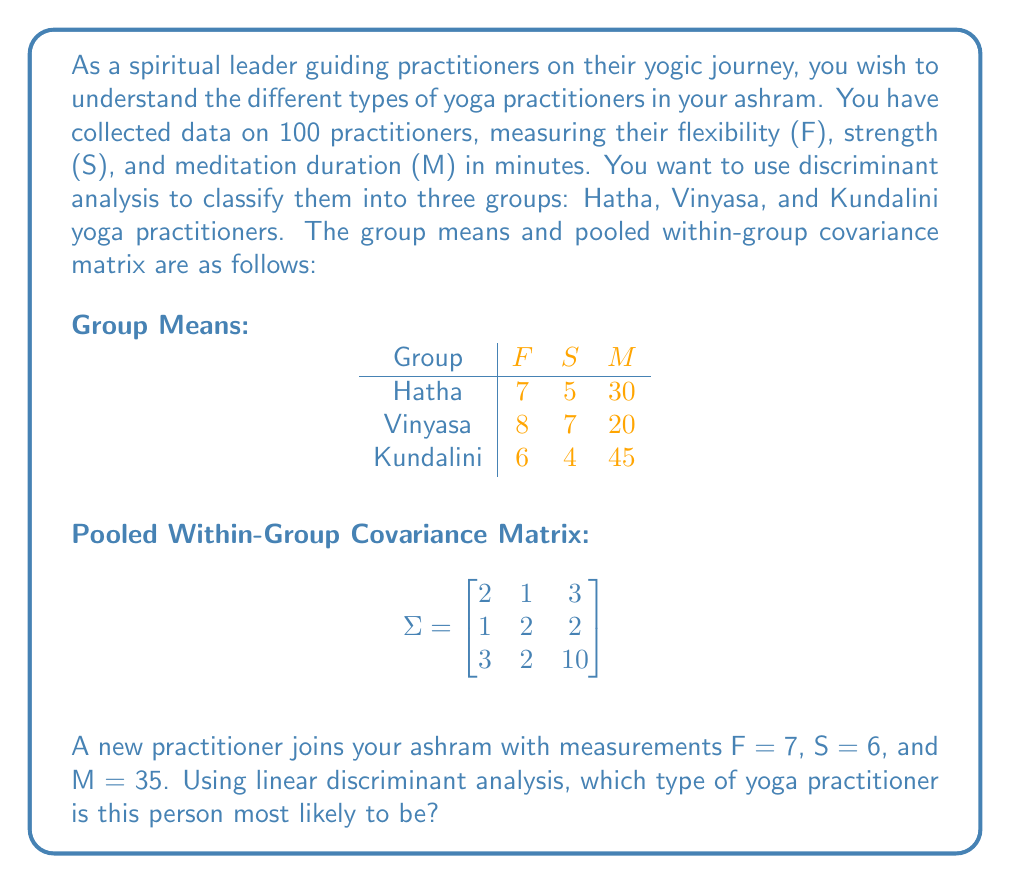Could you help me with this problem? To solve this problem using linear discriminant analysis, we'll follow these steps:

1) The linear discriminant function for each group is given by:
   $$d_k(x) = x^T \Sigma^{-1} \mu_k - \frac{1}{2} \mu_k^T \Sigma^{-1} \mu_k + \ln(p_k)$$
   where $x$ is the new observation, $\mu_k$ is the mean vector for group $k$, $\Sigma$ is the pooled within-group covariance matrix, and $p_k$ is the prior probability for group $k$.

2) Assuming equal prior probabilities, we can ignore the $\ln(p_k)$ term.

3) First, we need to find $\Sigma^{-1}$:
   $$\Sigma^{-1} = \begin{bmatrix}
   0.5714 & -0.1429 & -0.1714 \\
   -0.1429 & 0.5714 & -0.0571 \\
   -0.1714 & -0.0571 & 0.1429
   \end{bmatrix}$$

4) Now, let's calculate $\Sigma^{-1} \mu_k$ for each group:

   For Hatha: $\Sigma^{-1} \mu_\text{Hatha} = [1.2857, 1.0000, -0.4286]^T$
   For Vinyasa: $\Sigma^{-1} \mu_\text{Vinyasa} = [2.0000, 1.8571, -0.8571]^T$
   For Kundalini: $\Sigma^{-1} \mu_\text{Kundalini} = [0.4286, 0.2857, 0.2857]^T$

5) Calculate $\frac{1}{2} \mu_k^T \Sigma^{-1} \mu_k$ for each group:

   For Hatha: $\frac{1}{2} \mu_\text{Hatha}^T \Sigma^{-1} \mu_\text{Hatha} = 13.2143$
   For Vinyasa: $\frac{1}{2} \mu_\text{Vinyasa}^T \Sigma^{-1} \mu_\text{Vinyasa} = 17.7857$
   For Kundalini: $\frac{1}{2} \mu_\text{Kundalini}^T \Sigma^{-1} \mu_\text{Kundalini} = 11.7857$

6) Now we can calculate $d_k(x)$ for the new practitioner $x = [7, 6, 35]^T$:

   $d_\text{Hatha}(x) = [7, 6, 35] [1.2857, 1.0000, -0.4286]^T - 13.2143 = 9.0714$
   $d_\text{Vinyasa}(x) = [7, 6, 35] [2.0000, 1.8571, -0.8571]^T - 17.7857 = 8.2143$
   $d_\text{Kundalini}(x) = [7, 6, 35] [0.4286, 0.2857, 0.2857]^T - 11.7857 = 9.7143$

7) The largest discriminant function value corresponds to the most likely group. In this case, the largest value is 9.7143 for the Kundalini group.
Answer: Kundalini yoga practitioner 